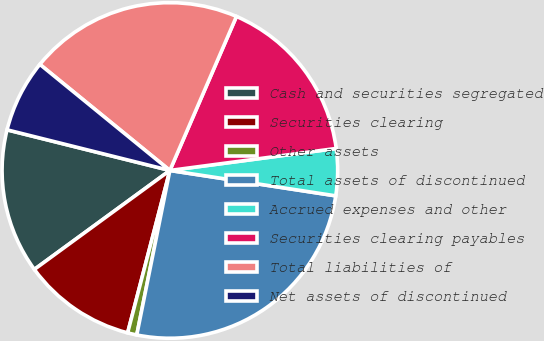<chart> <loc_0><loc_0><loc_500><loc_500><pie_chart><fcel>Cash and securities segregated<fcel>Securities clearing<fcel>Other assets<fcel>Total assets of discontinued<fcel>Accrued expenses and other<fcel>Securities clearing payables<fcel>Total liabilities of<fcel>Net assets of discontinued<nl><fcel>13.93%<fcel>10.91%<fcel>0.89%<fcel>25.74%<fcel>4.51%<fcel>16.41%<fcel>20.6%<fcel>7.0%<nl></chart> 